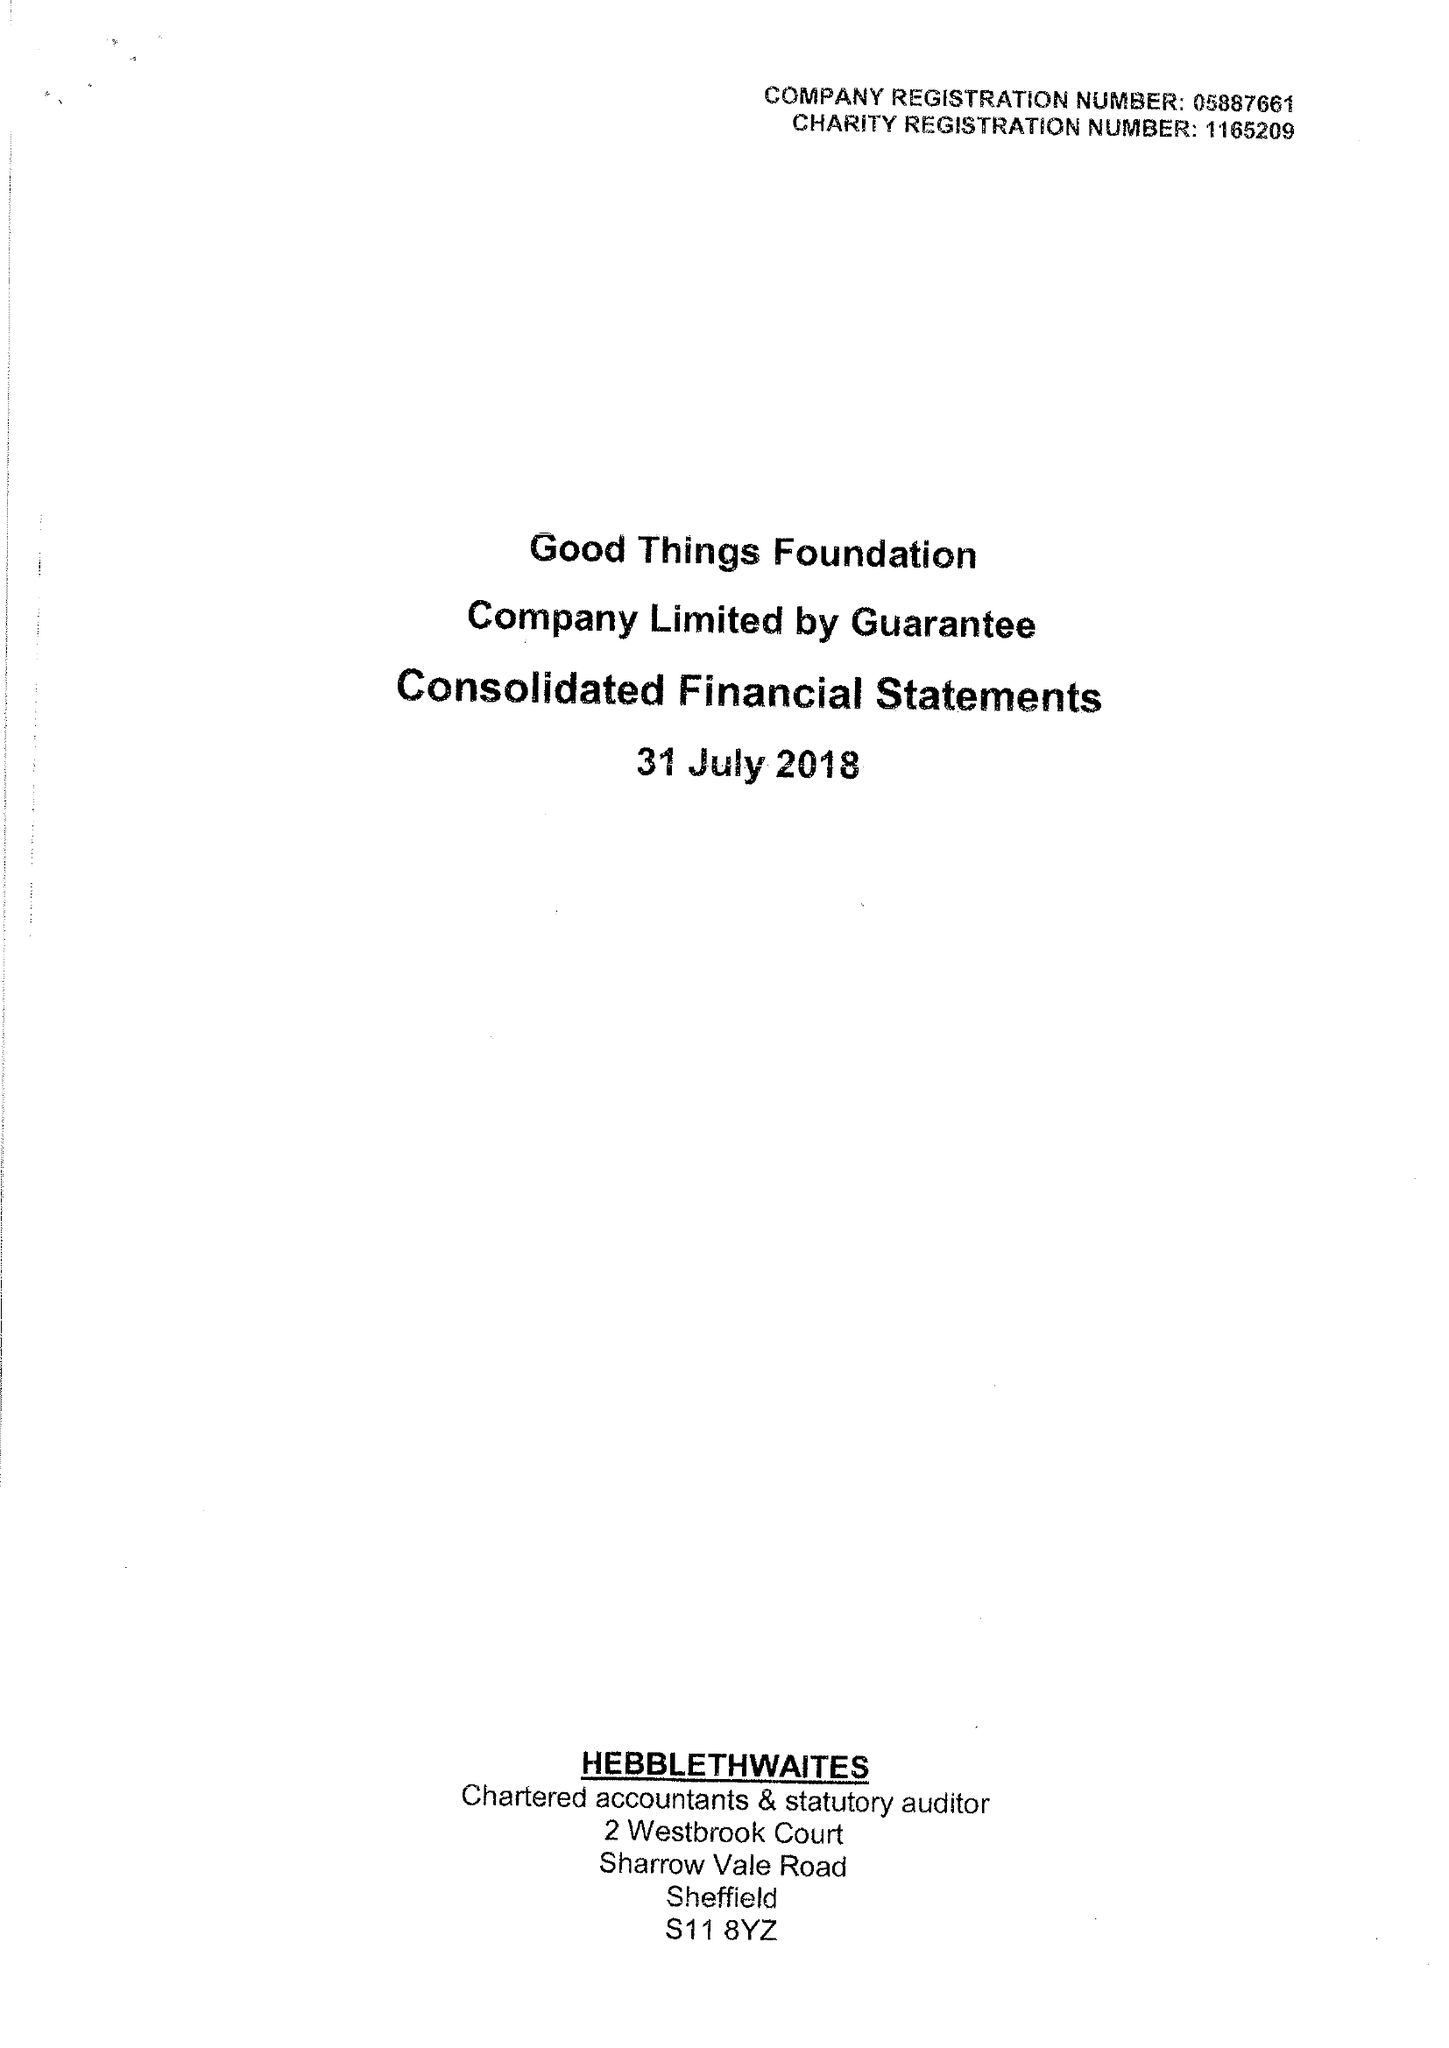What is the value for the charity_name?
Answer the question using a single word or phrase. Good Things Foundation 